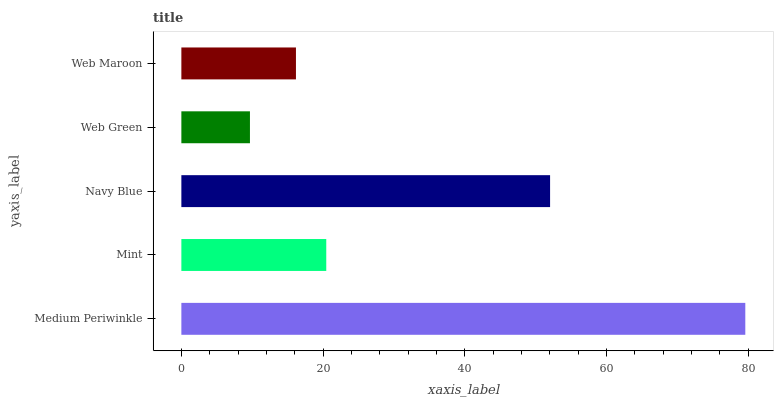Is Web Green the minimum?
Answer yes or no. Yes. Is Medium Periwinkle the maximum?
Answer yes or no. Yes. Is Mint the minimum?
Answer yes or no. No. Is Mint the maximum?
Answer yes or no. No. Is Medium Periwinkle greater than Mint?
Answer yes or no. Yes. Is Mint less than Medium Periwinkle?
Answer yes or no. Yes. Is Mint greater than Medium Periwinkle?
Answer yes or no. No. Is Medium Periwinkle less than Mint?
Answer yes or no. No. Is Mint the high median?
Answer yes or no. Yes. Is Mint the low median?
Answer yes or no. Yes. Is Web Green the high median?
Answer yes or no. No. Is Web Maroon the low median?
Answer yes or no. No. 